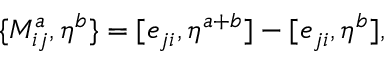Convert formula to latex. <formula><loc_0><loc_0><loc_500><loc_500>\{ M _ { i j } ^ { a } , \eta ^ { b } \} = [ e _ { j i } , \eta ^ { a + b } ] - [ e _ { j i } , \eta ^ { b } ] ,</formula> 